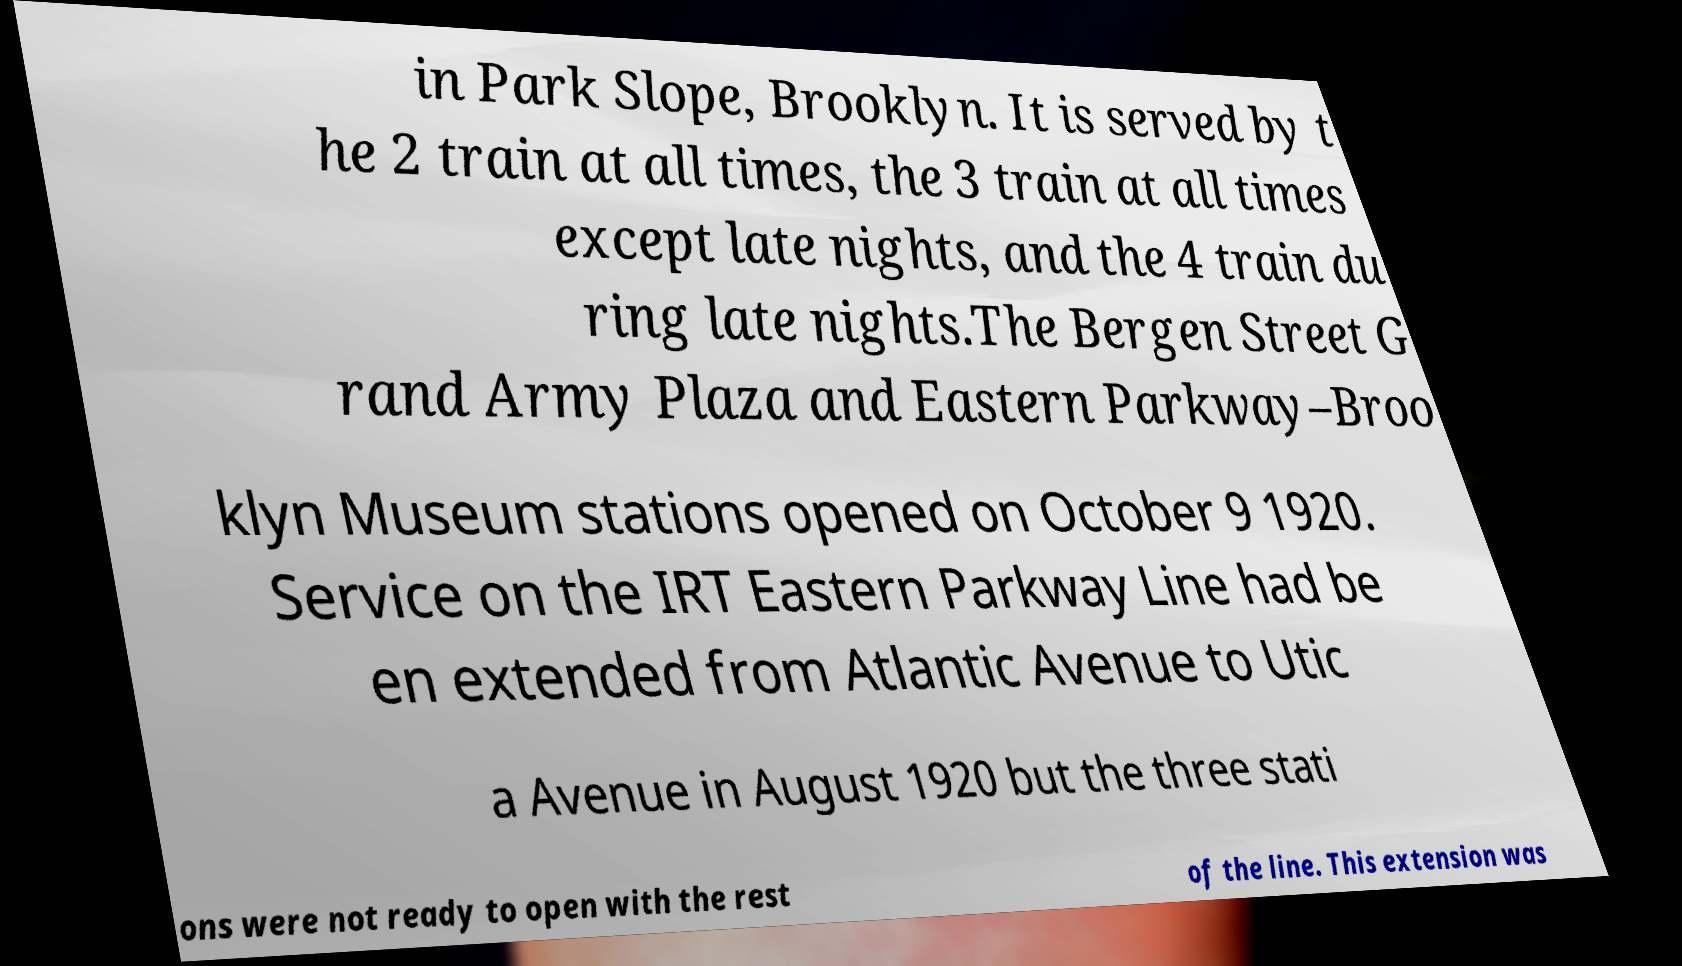For documentation purposes, I need the text within this image transcribed. Could you provide that? in Park Slope, Brooklyn. It is served by t he 2 train at all times, the 3 train at all times except late nights, and the 4 train du ring late nights.The Bergen Street G rand Army Plaza and Eastern Parkway–Broo klyn Museum stations opened on October 9 1920. Service on the IRT Eastern Parkway Line had be en extended from Atlantic Avenue to Utic a Avenue in August 1920 but the three stati ons were not ready to open with the rest of the line. This extension was 